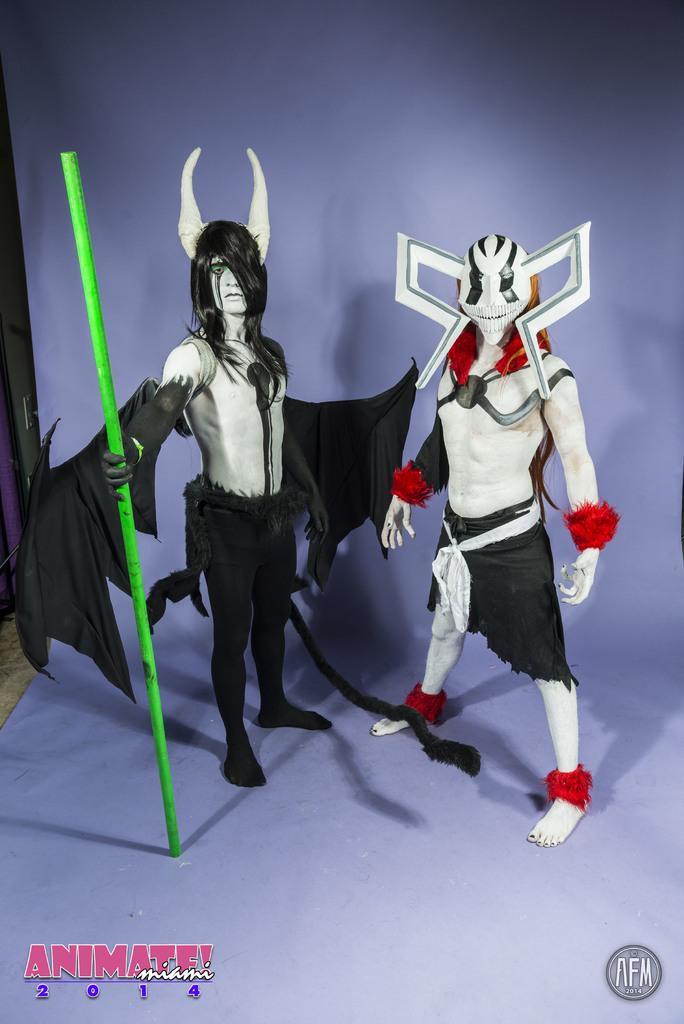Could you give a brief overview of what you see in this image? In this image, we can see two people are standing and wearing different costumes. Here a person is holding a stick. At the bottom of the image, there is a watermarks. 